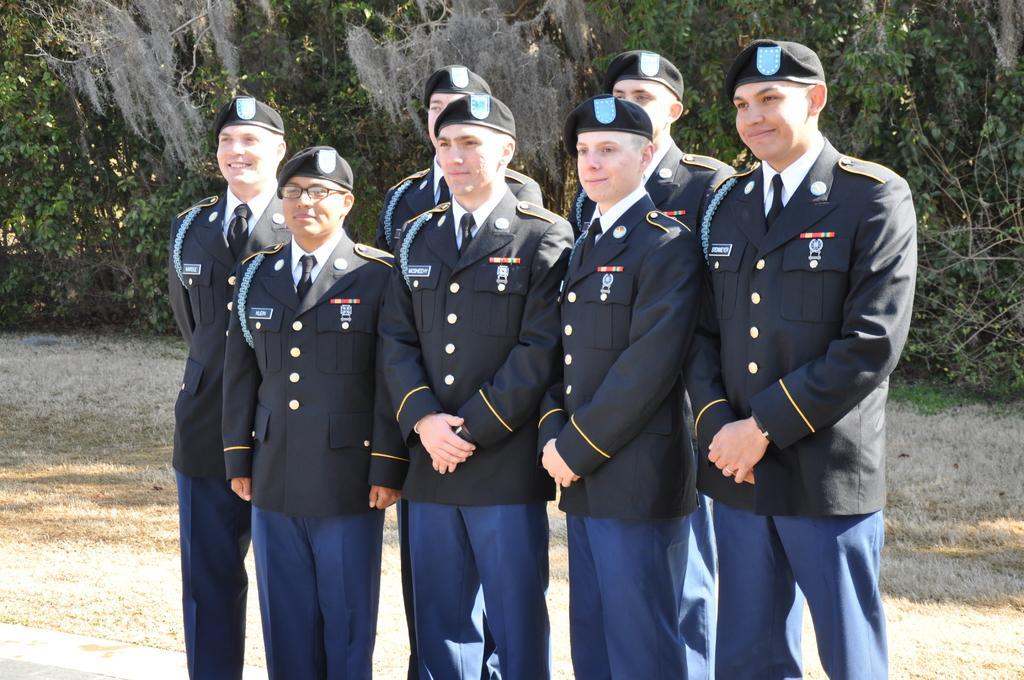Could you give a brief overview of what you see in this image? In this picture we can see some people are standing and taking pictures, back side we can see some trees. 